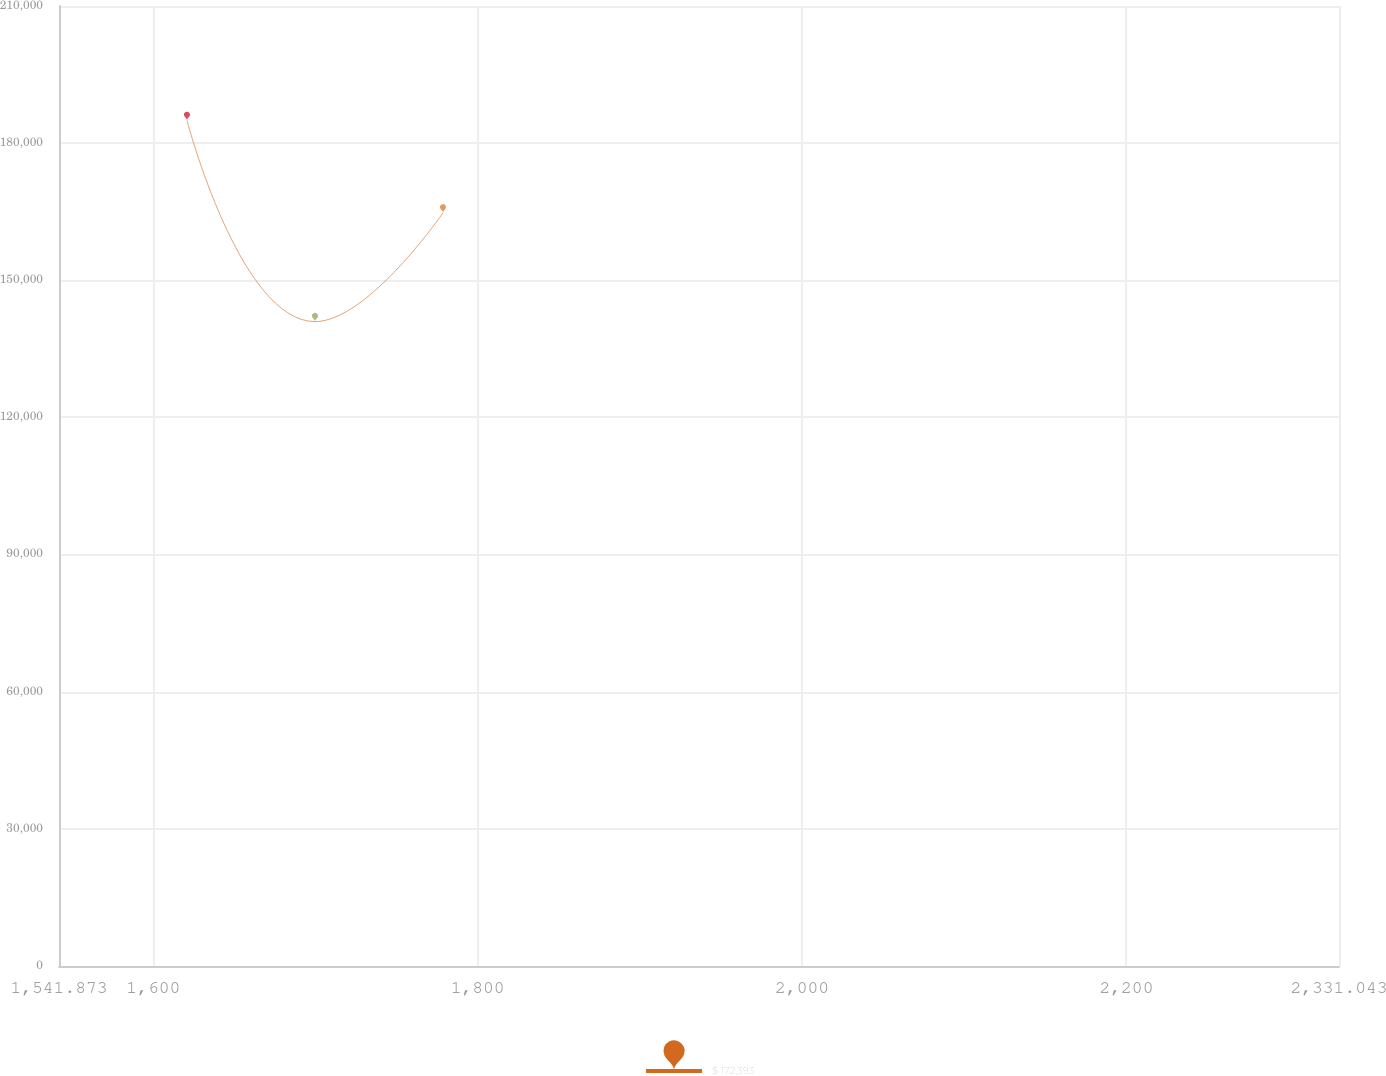<chart> <loc_0><loc_0><loc_500><loc_500><line_chart><ecel><fcel>$ 172,393<nl><fcel>1620.79<fcel>184943<nl><fcel>1699.71<fcel>140963<nl><fcel>1778.63<fcel>164761<nl><fcel>2409.96<fcel>121914<nl></chart> 